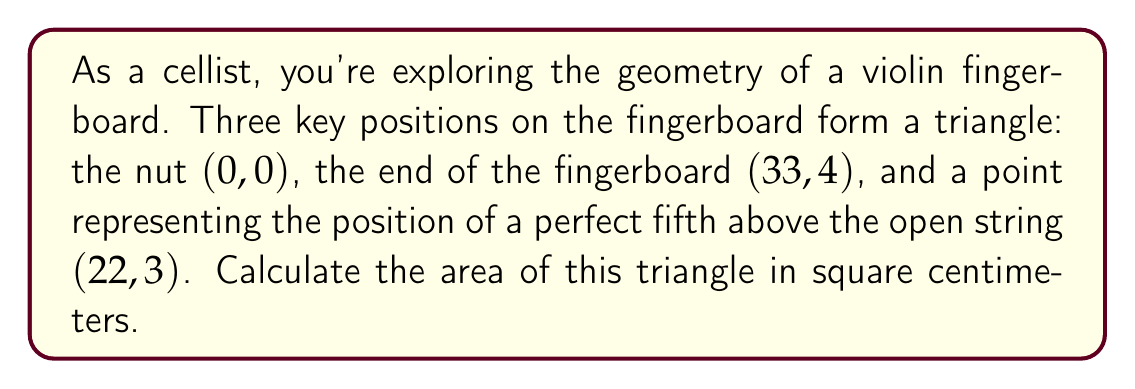Can you answer this question? To solve this problem, we'll use the formula for the area of a triangle given the coordinates of its vertices. Let's approach this step-by-step:

1) We have three points:
   A(0, 0), B(33, 4), and C(22, 3)

2) The formula for the area of a triangle given three points (x₁, y₁), (x₂, y₂), and (x₃, y₃) is:

   $$Area = \frac{1}{2}|x_1(y_2 - y_3) + x_2(y_3 - y_1) + x_3(y_1 - y_2)|$$

3) Let's substitute our values:

   $$Area = \frac{1}{2}|0(4 - 3) + 33(3 - 0) + 22(0 - 4)|$$

4) Simplify:

   $$Area = \frac{1}{2}|0(1) + 33(3) + 22(-4)|$$
   $$Area = \frac{1}{2}|0 + 99 - 88|$$
   $$Area = \frac{1}{2}|11|$$

5) Calculate:

   $$Area = \frac{11}{2} = 5.5$$

Therefore, the area of the triangle is 5.5 square centimeters.

[asy]
unitsize(5mm);
draw((0,0)--(33,4)--(22,3)--cycle);
dot((0,0));
dot((33,4));
dot((22,3));
label("A(0,0)", (0,0), SW);
label("B(33,4)", (33,4), NE);
label("C(22,3)", (22,3), N);
[/asy]
Answer: The area of the triangle is 5.5 square centimeters. 